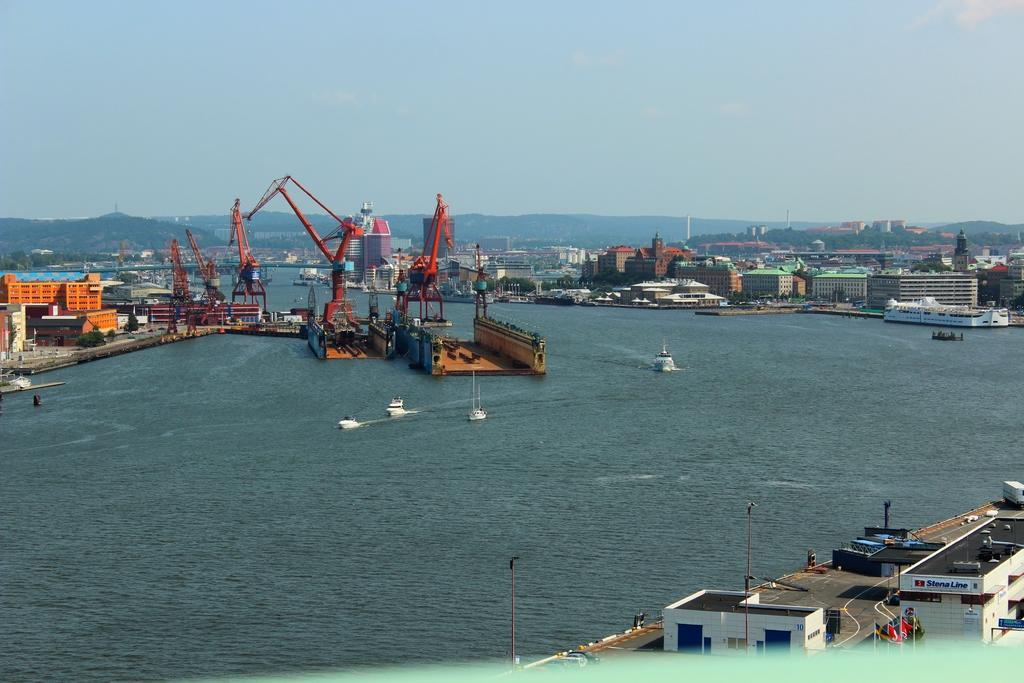Could you give a brief overview of what you see in this image? In this image I can see the water, few boats which are white in color on the surface of the water, few cranes which are orange in color, and few buildings which are orange, cream and white in color. In the background I can see few buildings, few trees, few mountains and the sky. 